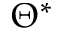Convert formula to latex. <formula><loc_0><loc_0><loc_500><loc_500>\Theta ^ { * }</formula> 